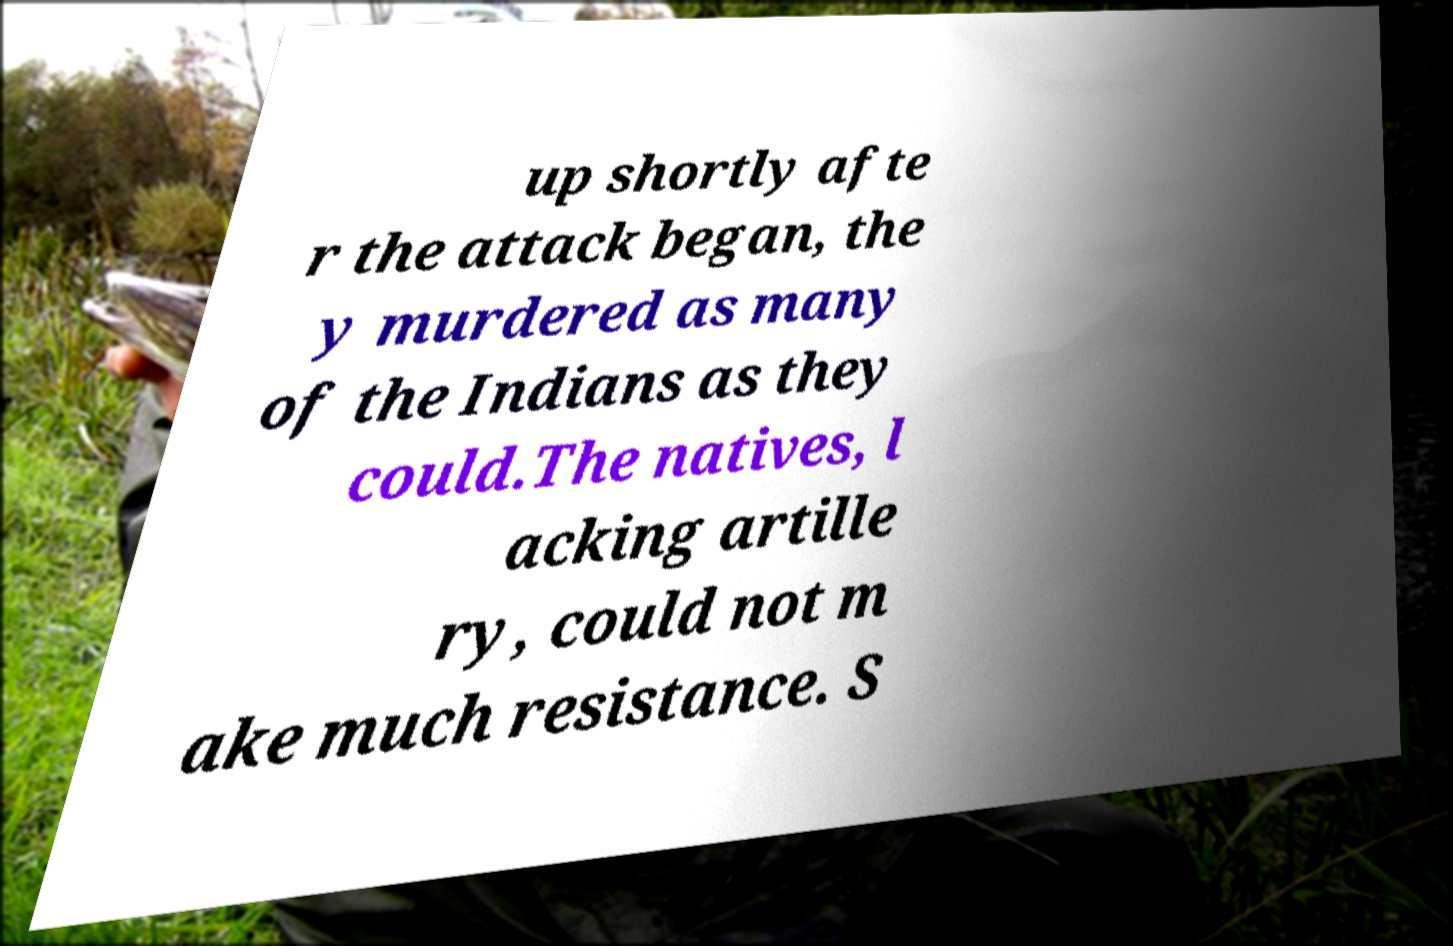Could you assist in decoding the text presented in this image and type it out clearly? up shortly afte r the attack began, the y murdered as many of the Indians as they could.The natives, l acking artille ry, could not m ake much resistance. S 